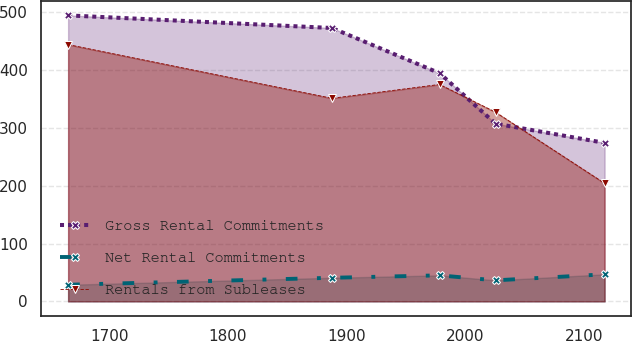<chart> <loc_0><loc_0><loc_500><loc_500><line_chart><ecel><fcel>Gross Rental Commitments<fcel>Net Rental Commitments<fcel>Rentals from Subleases<nl><fcel>1665.49<fcel>494.66<fcel>28.73<fcel>444.19<nl><fcel>1887.87<fcel>472.83<fcel>40.8<fcel>351.25<nl><fcel>1978.54<fcel>394.68<fcel>44.99<fcel>375.25<nl><fcel>2025.72<fcel>307.37<fcel>36.35<fcel>327.25<nl><fcel>2117.64<fcel>274.17<fcel>46.77<fcel>204.2<nl></chart> 